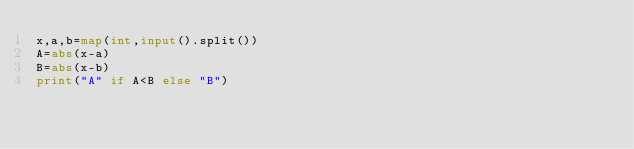<code> <loc_0><loc_0><loc_500><loc_500><_Python_>x,a,b=map(int,input().split())
A=abs(x-a)
B=abs(x-b)
print("A" if A<B else "B")</code> 